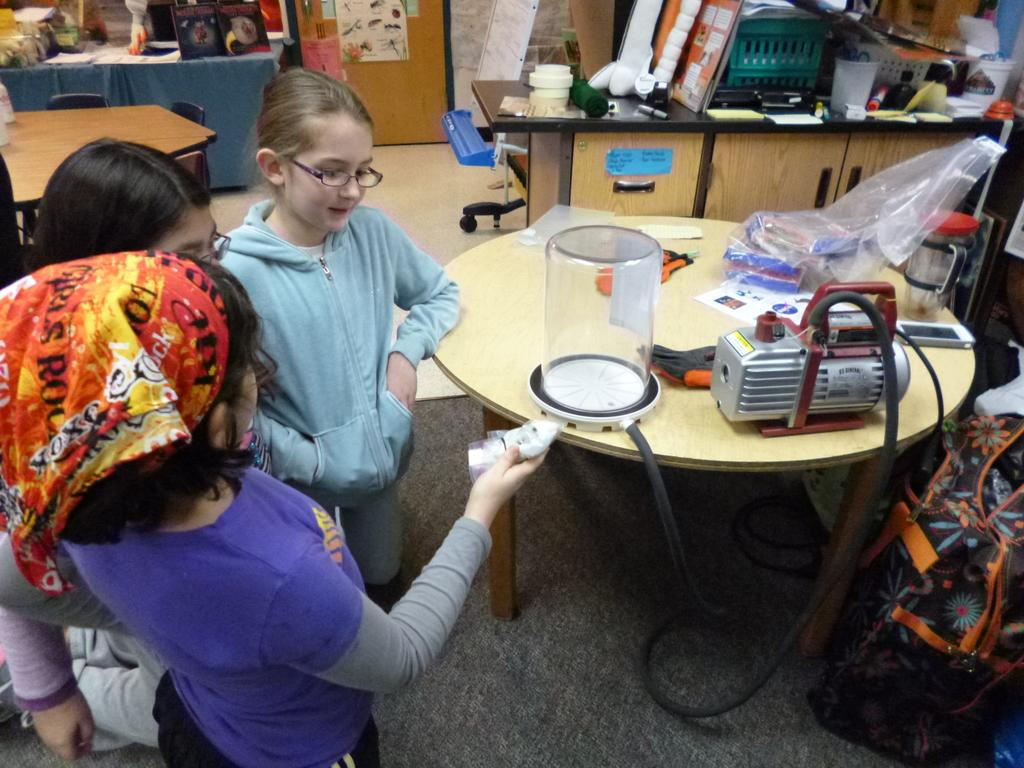What are the children in the image doing? The children are sitting on the floor in the image. What is in front of the children? There is a table in front of the children. What can be seen on the table? There are objects on the table. Can you describe the dining area in the image? There is a dining table in the image. How many bikes are parked near the children in the image? There are no bikes present in the image. What type of crush is the child on the left experiencing in the image? There is no indication of any emotional state or crush in the image. 